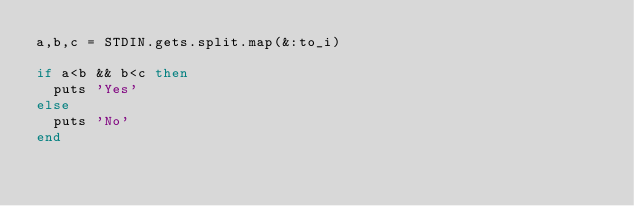Convert code to text. <code><loc_0><loc_0><loc_500><loc_500><_Ruby_>a,b,c = STDIN.gets.split.map(&:to_i)

if a<b && b<c then
  puts 'Yes'
else
  puts 'No'
end</code> 